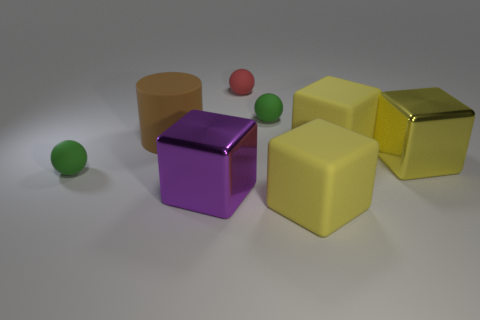Subtract all green balls. How many balls are left? 1 Subtract all purple blocks. How many blocks are left? 3 Subtract 2 spheres. How many spheres are left? 1 Add 1 small blue matte cylinders. How many objects exist? 9 Subtract all cylinders. How many objects are left? 7 Subtract all purple blocks. Subtract all yellow cylinders. How many blocks are left? 3 Subtract all red spheres. How many red cylinders are left? 0 Subtract all red spheres. Subtract all large gray shiny balls. How many objects are left? 7 Add 1 green things. How many green things are left? 3 Add 4 tiny balls. How many tiny balls exist? 7 